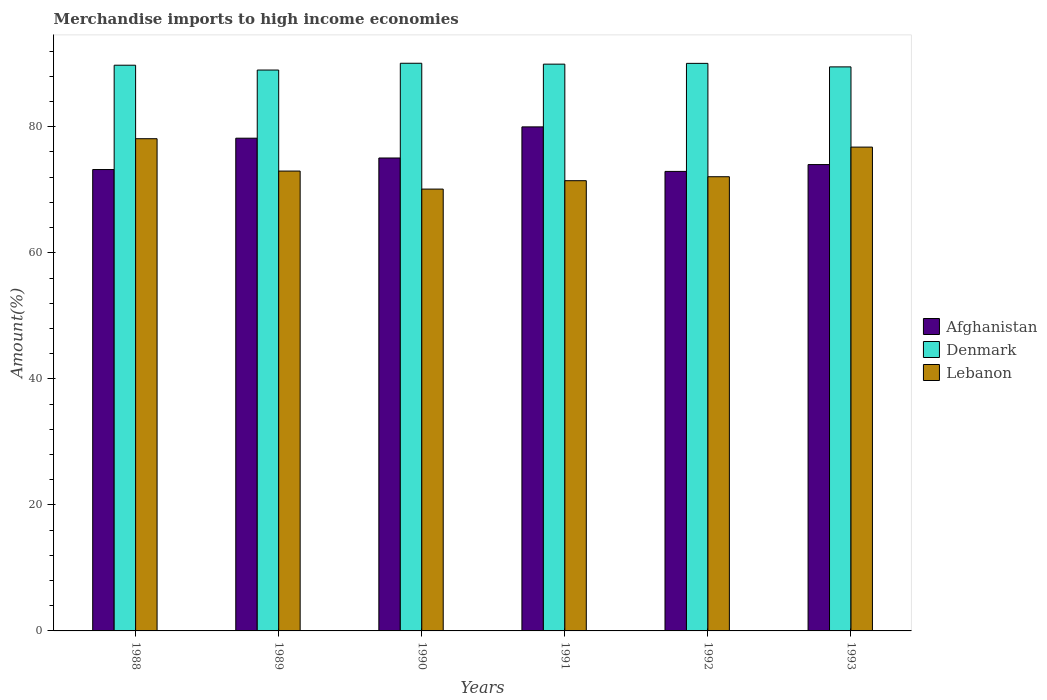How many different coloured bars are there?
Keep it short and to the point. 3. How many bars are there on the 5th tick from the left?
Give a very brief answer. 3. In how many cases, is the number of bars for a given year not equal to the number of legend labels?
Provide a succinct answer. 0. What is the percentage of amount earned from merchandise imports in Denmark in 1988?
Offer a very short reply. 89.77. Across all years, what is the maximum percentage of amount earned from merchandise imports in Denmark?
Provide a short and direct response. 90.08. Across all years, what is the minimum percentage of amount earned from merchandise imports in Afghanistan?
Your answer should be very brief. 72.92. In which year was the percentage of amount earned from merchandise imports in Denmark maximum?
Provide a short and direct response. 1990. In which year was the percentage of amount earned from merchandise imports in Afghanistan minimum?
Offer a terse response. 1992. What is the total percentage of amount earned from merchandise imports in Lebanon in the graph?
Keep it short and to the point. 441.48. What is the difference between the percentage of amount earned from merchandise imports in Lebanon in 1991 and that in 1993?
Your response must be concise. -5.33. What is the difference between the percentage of amount earned from merchandise imports in Afghanistan in 1992 and the percentage of amount earned from merchandise imports in Denmark in 1989?
Your answer should be very brief. -16.09. What is the average percentage of amount earned from merchandise imports in Lebanon per year?
Provide a short and direct response. 73.58. In the year 1989, what is the difference between the percentage of amount earned from merchandise imports in Denmark and percentage of amount earned from merchandise imports in Afghanistan?
Provide a succinct answer. 10.82. What is the ratio of the percentage of amount earned from merchandise imports in Denmark in 1988 to that in 1992?
Your answer should be very brief. 1. What is the difference between the highest and the second highest percentage of amount earned from merchandise imports in Afghanistan?
Offer a very short reply. 1.8. What is the difference between the highest and the lowest percentage of amount earned from merchandise imports in Denmark?
Make the answer very short. 1.08. Is the sum of the percentage of amount earned from merchandise imports in Lebanon in 1989 and 1991 greater than the maximum percentage of amount earned from merchandise imports in Afghanistan across all years?
Make the answer very short. Yes. What does the 1st bar from the left in 1990 represents?
Your answer should be compact. Afghanistan. What does the 1st bar from the right in 1993 represents?
Your answer should be compact. Lebanon. Is it the case that in every year, the sum of the percentage of amount earned from merchandise imports in Denmark and percentage of amount earned from merchandise imports in Lebanon is greater than the percentage of amount earned from merchandise imports in Afghanistan?
Your answer should be very brief. Yes. How many bars are there?
Your answer should be very brief. 18. What is the difference between two consecutive major ticks on the Y-axis?
Make the answer very short. 20. Does the graph contain any zero values?
Offer a very short reply. No. Where does the legend appear in the graph?
Provide a short and direct response. Center right. How many legend labels are there?
Offer a terse response. 3. How are the legend labels stacked?
Your response must be concise. Vertical. What is the title of the graph?
Your answer should be compact. Merchandise imports to high income economies. What is the label or title of the X-axis?
Offer a very short reply. Years. What is the label or title of the Y-axis?
Provide a short and direct response. Amount(%). What is the Amount(%) in Afghanistan in 1988?
Your answer should be very brief. 73.21. What is the Amount(%) of Denmark in 1988?
Your response must be concise. 89.77. What is the Amount(%) in Lebanon in 1988?
Keep it short and to the point. 78.1. What is the Amount(%) of Afghanistan in 1989?
Keep it short and to the point. 78.19. What is the Amount(%) in Denmark in 1989?
Provide a succinct answer. 89. What is the Amount(%) of Lebanon in 1989?
Give a very brief answer. 72.97. What is the Amount(%) in Afghanistan in 1990?
Your answer should be very brief. 75.05. What is the Amount(%) of Denmark in 1990?
Offer a terse response. 90.08. What is the Amount(%) of Lebanon in 1990?
Provide a succinct answer. 70.11. What is the Amount(%) of Afghanistan in 1991?
Your response must be concise. 79.98. What is the Amount(%) in Denmark in 1991?
Provide a short and direct response. 89.94. What is the Amount(%) in Lebanon in 1991?
Make the answer very short. 71.44. What is the Amount(%) of Afghanistan in 1992?
Your answer should be very brief. 72.92. What is the Amount(%) in Denmark in 1992?
Your response must be concise. 90.06. What is the Amount(%) in Lebanon in 1992?
Your answer should be compact. 72.07. What is the Amount(%) of Afghanistan in 1993?
Keep it short and to the point. 74. What is the Amount(%) of Denmark in 1993?
Provide a succinct answer. 89.5. What is the Amount(%) in Lebanon in 1993?
Keep it short and to the point. 76.78. Across all years, what is the maximum Amount(%) in Afghanistan?
Offer a terse response. 79.98. Across all years, what is the maximum Amount(%) in Denmark?
Provide a short and direct response. 90.08. Across all years, what is the maximum Amount(%) of Lebanon?
Your answer should be very brief. 78.1. Across all years, what is the minimum Amount(%) in Afghanistan?
Your answer should be very brief. 72.92. Across all years, what is the minimum Amount(%) of Denmark?
Offer a terse response. 89. Across all years, what is the minimum Amount(%) of Lebanon?
Offer a very short reply. 70.11. What is the total Amount(%) in Afghanistan in the graph?
Make the answer very short. 453.35. What is the total Amount(%) of Denmark in the graph?
Give a very brief answer. 538.35. What is the total Amount(%) in Lebanon in the graph?
Your answer should be compact. 441.48. What is the difference between the Amount(%) of Afghanistan in 1988 and that in 1989?
Your response must be concise. -4.97. What is the difference between the Amount(%) of Denmark in 1988 and that in 1989?
Give a very brief answer. 0.77. What is the difference between the Amount(%) of Lebanon in 1988 and that in 1989?
Your response must be concise. 5.14. What is the difference between the Amount(%) of Afghanistan in 1988 and that in 1990?
Your answer should be very brief. -1.83. What is the difference between the Amount(%) of Denmark in 1988 and that in 1990?
Give a very brief answer. -0.31. What is the difference between the Amount(%) of Lebanon in 1988 and that in 1990?
Make the answer very short. 7.99. What is the difference between the Amount(%) of Afghanistan in 1988 and that in 1991?
Your answer should be very brief. -6.77. What is the difference between the Amount(%) of Denmark in 1988 and that in 1991?
Provide a short and direct response. -0.17. What is the difference between the Amount(%) of Lebanon in 1988 and that in 1991?
Ensure brevity in your answer.  6.66. What is the difference between the Amount(%) of Afghanistan in 1988 and that in 1992?
Your answer should be very brief. 0.3. What is the difference between the Amount(%) of Denmark in 1988 and that in 1992?
Keep it short and to the point. -0.29. What is the difference between the Amount(%) of Lebanon in 1988 and that in 1992?
Provide a short and direct response. 6.03. What is the difference between the Amount(%) in Afghanistan in 1988 and that in 1993?
Offer a very short reply. -0.79. What is the difference between the Amount(%) in Denmark in 1988 and that in 1993?
Offer a terse response. 0.27. What is the difference between the Amount(%) in Lebanon in 1988 and that in 1993?
Your answer should be compact. 1.33. What is the difference between the Amount(%) of Afghanistan in 1989 and that in 1990?
Give a very brief answer. 3.14. What is the difference between the Amount(%) of Denmark in 1989 and that in 1990?
Your answer should be compact. -1.08. What is the difference between the Amount(%) of Lebanon in 1989 and that in 1990?
Your response must be concise. 2.86. What is the difference between the Amount(%) of Afghanistan in 1989 and that in 1991?
Provide a short and direct response. -1.8. What is the difference between the Amount(%) of Denmark in 1989 and that in 1991?
Offer a very short reply. -0.93. What is the difference between the Amount(%) in Lebanon in 1989 and that in 1991?
Offer a very short reply. 1.53. What is the difference between the Amount(%) in Afghanistan in 1989 and that in 1992?
Offer a terse response. 5.27. What is the difference between the Amount(%) in Denmark in 1989 and that in 1992?
Keep it short and to the point. -1.06. What is the difference between the Amount(%) of Lebanon in 1989 and that in 1992?
Give a very brief answer. 0.9. What is the difference between the Amount(%) of Afghanistan in 1989 and that in 1993?
Provide a succinct answer. 4.19. What is the difference between the Amount(%) of Denmark in 1989 and that in 1993?
Ensure brevity in your answer.  -0.5. What is the difference between the Amount(%) of Lebanon in 1989 and that in 1993?
Your answer should be very brief. -3.81. What is the difference between the Amount(%) of Afghanistan in 1990 and that in 1991?
Make the answer very short. -4.94. What is the difference between the Amount(%) of Denmark in 1990 and that in 1991?
Make the answer very short. 0.14. What is the difference between the Amount(%) of Lebanon in 1990 and that in 1991?
Offer a terse response. -1.33. What is the difference between the Amount(%) in Afghanistan in 1990 and that in 1992?
Your answer should be very brief. 2.13. What is the difference between the Amount(%) in Denmark in 1990 and that in 1992?
Offer a very short reply. 0.02. What is the difference between the Amount(%) in Lebanon in 1990 and that in 1992?
Offer a very short reply. -1.96. What is the difference between the Amount(%) in Afghanistan in 1990 and that in 1993?
Give a very brief answer. 1.04. What is the difference between the Amount(%) of Denmark in 1990 and that in 1993?
Offer a terse response. 0.58. What is the difference between the Amount(%) of Lebanon in 1990 and that in 1993?
Make the answer very short. -6.66. What is the difference between the Amount(%) in Afghanistan in 1991 and that in 1992?
Your response must be concise. 7.07. What is the difference between the Amount(%) in Denmark in 1991 and that in 1992?
Offer a very short reply. -0.12. What is the difference between the Amount(%) of Lebanon in 1991 and that in 1992?
Your response must be concise. -0.63. What is the difference between the Amount(%) in Afghanistan in 1991 and that in 1993?
Give a very brief answer. 5.98. What is the difference between the Amount(%) in Denmark in 1991 and that in 1993?
Provide a succinct answer. 0.43. What is the difference between the Amount(%) of Lebanon in 1991 and that in 1993?
Give a very brief answer. -5.33. What is the difference between the Amount(%) of Afghanistan in 1992 and that in 1993?
Provide a short and direct response. -1.09. What is the difference between the Amount(%) in Denmark in 1992 and that in 1993?
Ensure brevity in your answer.  0.56. What is the difference between the Amount(%) in Lebanon in 1992 and that in 1993?
Give a very brief answer. -4.7. What is the difference between the Amount(%) of Afghanistan in 1988 and the Amount(%) of Denmark in 1989?
Your response must be concise. -15.79. What is the difference between the Amount(%) of Afghanistan in 1988 and the Amount(%) of Lebanon in 1989?
Your answer should be very brief. 0.24. What is the difference between the Amount(%) in Denmark in 1988 and the Amount(%) in Lebanon in 1989?
Your answer should be very brief. 16.8. What is the difference between the Amount(%) of Afghanistan in 1988 and the Amount(%) of Denmark in 1990?
Your answer should be compact. -16.86. What is the difference between the Amount(%) in Afghanistan in 1988 and the Amount(%) in Lebanon in 1990?
Keep it short and to the point. 3.1. What is the difference between the Amount(%) in Denmark in 1988 and the Amount(%) in Lebanon in 1990?
Provide a short and direct response. 19.66. What is the difference between the Amount(%) in Afghanistan in 1988 and the Amount(%) in Denmark in 1991?
Your response must be concise. -16.72. What is the difference between the Amount(%) of Afghanistan in 1988 and the Amount(%) of Lebanon in 1991?
Give a very brief answer. 1.77. What is the difference between the Amount(%) in Denmark in 1988 and the Amount(%) in Lebanon in 1991?
Make the answer very short. 18.33. What is the difference between the Amount(%) in Afghanistan in 1988 and the Amount(%) in Denmark in 1992?
Offer a very short reply. -16.85. What is the difference between the Amount(%) in Afghanistan in 1988 and the Amount(%) in Lebanon in 1992?
Provide a succinct answer. 1.14. What is the difference between the Amount(%) in Denmark in 1988 and the Amount(%) in Lebanon in 1992?
Offer a terse response. 17.7. What is the difference between the Amount(%) of Afghanistan in 1988 and the Amount(%) of Denmark in 1993?
Offer a terse response. -16.29. What is the difference between the Amount(%) in Afghanistan in 1988 and the Amount(%) in Lebanon in 1993?
Provide a short and direct response. -3.56. What is the difference between the Amount(%) of Denmark in 1988 and the Amount(%) of Lebanon in 1993?
Provide a short and direct response. 12.99. What is the difference between the Amount(%) of Afghanistan in 1989 and the Amount(%) of Denmark in 1990?
Keep it short and to the point. -11.89. What is the difference between the Amount(%) of Afghanistan in 1989 and the Amount(%) of Lebanon in 1990?
Provide a succinct answer. 8.07. What is the difference between the Amount(%) in Denmark in 1989 and the Amount(%) in Lebanon in 1990?
Keep it short and to the point. 18.89. What is the difference between the Amount(%) of Afghanistan in 1989 and the Amount(%) of Denmark in 1991?
Provide a short and direct response. -11.75. What is the difference between the Amount(%) of Afghanistan in 1989 and the Amount(%) of Lebanon in 1991?
Make the answer very short. 6.74. What is the difference between the Amount(%) in Denmark in 1989 and the Amount(%) in Lebanon in 1991?
Offer a terse response. 17.56. What is the difference between the Amount(%) in Afghanistan in 1989 and the Amount(%) in Denmark in 1992?
Provide a succinct answer. -11.87. What is the difference between the Amount(%) in Afghanistan in 1989 and the Amount(%) in Lebanon in 1992?
Offer a terse response. 6.11. What is the difference between the Amount(%) in Denmark in 1989 and the Amount(%) in Lebanon in 1992?
Give a very brief answer. 16.93. What is the difference between the Amount(%) of Afghanistan in 1989 and the Amount(%) of Denmark in 1993?
Ensure brevity in your answer.  -11.32. What is the difference between the Amount(%) in Afghanistan in 1989 and the Amount(%) in Lebanon in 1993?
Your answer should be compact. 1.41. What is the difference between the Amount(%) in Denmark in 1989 and the Amount(%) in Lebanon in 1993?
Make the answer very short. 12.23. What is the difference between the Amount(%) of Afghanistan in 1990 and the Amount(%) of Denmark in 1991?
Give a very brief answer. -14.89. What is the difference between the Amount(%) in Afghanistan in 1990 and the Amount(%) in Lebanon in 1991?
Your answer should be compact. 3.6. What is the difference between the Amount(%) of Denmark in 1990 and the Amount(%) of Lebanon in 1991?
Ensure brevity in your answer.  18.63. What is the difference between the Amount(%) of Afghanistan in 1990 and the Amount(%) of Denmark in 1992?
Ensure brevity in your answer.  -15.01. What is the difference between the Amount(%) in Afghanistan in 1990 and the Amount(%) in Lebanon in 1992?
Your answer should be compact. 2.97. What is the difference between the Amount(%) in Denmark in 1990 and the Amount(%) in Lebanon in 1992?
Provide a short and direct response. 18.01. What is the difference between the Amount(%) of Afghanistan in 1990 and the Amount(%) of Denmark in 1993?
Your response must be concise. -14.46. What is the difference between the Amount(%) in Afghanistan in 1990 and the Amount(%) in Lebanon in 1993?
Provide a succinct answer. -1.73. What is the difference between the Amount(%) of Denmark in 1990 and the Amount(%) of Lebanon in 1993?
Offer a very short reply. 13.3. What is the difference between the Amount(%) of Afghanistan in 1991 and the Amount(%) of Denmark in 1992?
Offer a very short reply. -10.08. What is the difference between the Amount(%) of Afghanistan in 1991 and the Amount(%) of Lebanon in 1992?
Make the answer very short. 7.91. What is the difference between the Amount(%) of Denmark in 1991 and the Amount(%) of Lebanon in 1992?
Offer a very short reply. 17.86. What is the difference between the Amount(%) in Afghanistan in 1991 and the Amount(%) in Denmark in 1993?
Ensure brevity in your answer.  -9.52. What is the difference between the Amount(%) in Afghanistan in 1991 and the Amount(%) in Lebanon in 1993?
Provide a short and direct response. 3.21. What is the difference between the Amount(%) in Denmark in 1991 and the Amount(%) in Lebanon in 1993?
Give a very brief answer. 13.16. What is the difference between the Amount(%) of Afghanistan in 1992 and the Amount(%) of Denmark in 1993?
Provide a succinct answer. -16.59. What is the difference between the Amount(%) in Afghanistan in 1992 and the Amount(%) in Lebanon in 1993?
Provide a succinct answer. -3.86. What is the difference between the Amount(%) of Denmark in 1992 and the Amount(%) of Lebanon in 1993?
Your answer should be compact. 13.29. What is the average Amount(%) of Afghanistan per year?
Give a very brief answer. 75.56. What is the average Amount(%) in Denmark per year?
Give a very brief answer. 89.73. What is the average Amount(%) of Lebanon per year?
Your response must be concise. 73.58. In the year 1988, what is the difference between the Amount(%) of Afghanistan and Amount(%) of Denmark?
Provide a short and direct response. -16.56. In the year 1988, what is the difference between the Amount(%) in Afghanistan and Amount(%) in Lebanon?
Your response must be concise. -4.89. In the year 1988, what is the difference between the Amount(%) of Denmark and Amount(%) of Lebanon?
Your answer should be compact. 11.67. In the year 1989, what is the difference between the Amount(%) in Afghanistan and Amount(%) in Denmark?
Make the answer very short. -10.82. In the year 1989, what is the difference between the Amount(%) of Afghanistan and Amount(%) of Lebanon?
Your answer should be very brief. 5.22. In the year 1989, what is the difference between the Amount(%) of Denmark and Amount(%) of Lebanon?
Provide a succinct answer. 16.03. In the year 1990, what is the difference between the Amount(%) in Afghanistan and Amount(%) in Denmark?
Your response must be concise. -15.03. In the year 1990, what is the difference between the Amount(%) of Afghanistan and Amount(%) of Lebanon?
Your response must be concise. 4.93. In the year 1990, what is the difference between the Amount(%) of Denmark and Amount(%) of Lebanon?
Offer a terse response. 19.97. In the year 1991, what is the difference between the Amount(%) of Afghanistan and Amount(%) of Denmark?
Your response must be concise. -9.95. In the year 1991, what is the difference between the Amount(%) in Afghanistan and Amount(%) in Lebanon?
Your answer should be compact. 8.54. In the year 1991, what is the difference between the Amount(%) in Denmark and Amount(%) in Lebanon?
Give a very brief answer. 18.49. In the year 1992, what is the difference between the Amount(%) of Afghanistan and Amount(%) of Denmark?
Ensure brevity in your answer.  -17.15. In the year 1992, what is the difference between the Amount(%) in Afghanistan and Amount(%) in Lebanon?
Make the answer very short. 0.84. In the year 1992, what is the difference between the Amount(%) in Denmark and Amount(%) in Lebanon?
Keep it short and to the point. 17.99. In the year 1993, what is the difference between the Amount(%) in Afghanistan and Amount(%) in Denmark?
Ensure brevity in your answer.  -15.5. In the year 1993, what is the difference between the Amount(%) of Afghanistan and Amount(%) of Lebanon?
Make the answer very short. -2.77. In the year 1993, what is the difference between the Amount(%) in Denmark and Amount(%) in Lebanon?
Your answer should be compact. 12.73. What is the ratio of the Amount(%) of Afghanistan in 1988 to that in 1989?
Provide a short and direct response. 0.94. What is the ratio of the Amount(%) in Denmark in 1988 to that in 1989?
Your response must be concise. 1.01. What is the ratio of the Amount(%) in Lebanon in 1988 to that in 1989?
Ensure brevity in your answer.  1.07. What is the ratio of the Amount(%) of Afghanistan in 1988 to that in 1990?
Make the answer very short. 0.98. What is the ratio of the Amount(%) of Denmark in 1988 to that in 1990?
Your answer should be very brief. 1. What is the ratio of the Amount(%) of Lebanon in 1988 to that in 1990?
Provide a short and direct response. 1.11. What is the ratio of the Amount(%) of Afghanistan in 1988 to that in 1991?
Your answer should be very brief. 0.92. What is the ratio of the Amount(%) in Denmark in 1988 to that in 1991?
Ensure brevity in your answer.  1. What is the ratio of the Amount(%) of Lebanon in 1988 to that in 1991?
Provide a succinct answer. 1.09. What is the ratio of the Amount(%) of Denmark in 1988 to that in 1992?
Keep it short and to the point. 1. What is the ratio of the Amount(%) of Lebanon in 1988 to that in 1992?
Give a very brief answer. 1.08. What is the ratio of the Amount(%) in Denmark in 1988 to that in 1993?
Your answer should be very brief. 1. What is the ratio of the Amount(%) in Lebanon in 1988 to that in 1993?
Your answer should be compact. 1.02. What is the ratio of the Amount(%) of Afghanistan in 1989 to that in 1990?
Provide a succinct answer. 1.04. What is the ratio of the Amount(%) of Denmark in 1989 to that in 1990?
Your answer should be very brief. 0.99. What is the ratio of the Amount(%) of Lebanon in 1989 to that in 1990?
Provide a short and direct response. 1.04. What is the ratio of the Amount(%) in Afghanistan in 1989 to that in 1991?
Provide a succinct answer. 0.98. What is the ratio of the Amount(%) in Lebanon in 1989 to that in 1991?
Offer a very short reply. 1.02. What is the ratio of the Amount(%) of Afghanistan in 1989 to that in 1992?
Provide a short and direct response. 1.07. What is the ratio of the Amount(%) of Denmark in 1989 to that in 1992?
Your response must be concise. 0.99. What is the ratio of the Amount(%) in Lebanon in 1989 to that in 1992?
Offer a terse response. 1.01. What is the ratio of the Amount(%) of Afghanistan in 1989 to that in 1993?
Your answer should be compact. 1.06. What is the ratio of the Amount(%) of Denmark in 1989 to that in 1993?
Offer a very short reply. 0.99. What is the ratio of the Amount(%) in Lebanon in 1989 to that in 1993?
Provide a succinct answer. 0.95. What is the ratio of the Amount(%) of Afghanistan in 1990 to that in 1991?
Keep it short and to the point. 0.94. What is the ratio of the Amount(%) of Lebanon in 1990 to that in 1991?
Ensure brevity in your answer.  0.98. What is the ratio of the Amount(%) in Afghanistan in 1990 to that in 1992?
Make the answer very short. 1.03. What is the ratio of the Amount(%) of Lebanon in 1990 to that in 1992?
Keep it short and to the point. 0.97. What is the ratio of the Amount(%) of Afghanistan in 1990 to that in 1993?
Provide a succinct answer. 1.01. What is the ratio of the Amount(%) in Denmark in 1990 to that in 1993?
Offer a very short reply. 1.01. What is the ratio of the Amount(%) in Lebanon in 1990 to that in 1993?
Provide a succinct answer. 0.91. What is the ratio of the Amount(%) of Afghanistan in 1991 to that in 1992?
Give a very brief answer. 1.1. What is the ratio of the Amount(%) in Denmark in 1991 to that in 1992?
Offer a terse response. 1. What is the ratio of the Amount(%) in Afghanistan in 1991 to that in 1993?
Offer a very short reply. 1.08. What is the ratio of the Amount(%) of Denmark in 1991 to that in 1993?
Your response must be concise. 1. What is the ratio of the Amount(%) in Lebanon in 1991 to that in 1993?
Provide a succinct answer. 0.93. What is the ratio of the Amount(%) of Afghanistan in 1992 to that in 1993?
Offer a terse response. 0.99. What is the ratio of the Amount(%) in Lebanon in 1992 to that in 1993?
Provide a succinct answer. 0.94. What is the difference between the highest and the second highest Amount(%) in Afghanistan?
Ensure brevity in your answer.  1.8. What is the difference between the highest and the second highest Amount(%) of Denmark?
Your answer should be very brief. 0.02. What is the difference between the highest and the second highest Amount(%) in Lebanon?
Provide a succinct answer. 1.33. What is the difference between the highest and the lowest Amount(%) of Afghanistan?
Make the answer very short. 7.07. What is the difference between the highest and the lowest Amount(%) in Denmark?
Your answer should be compact. 1.08. What is the difference between the highest and the lowest Amount(%) in Lebanon?
Your answer should be compact. 7.99. 